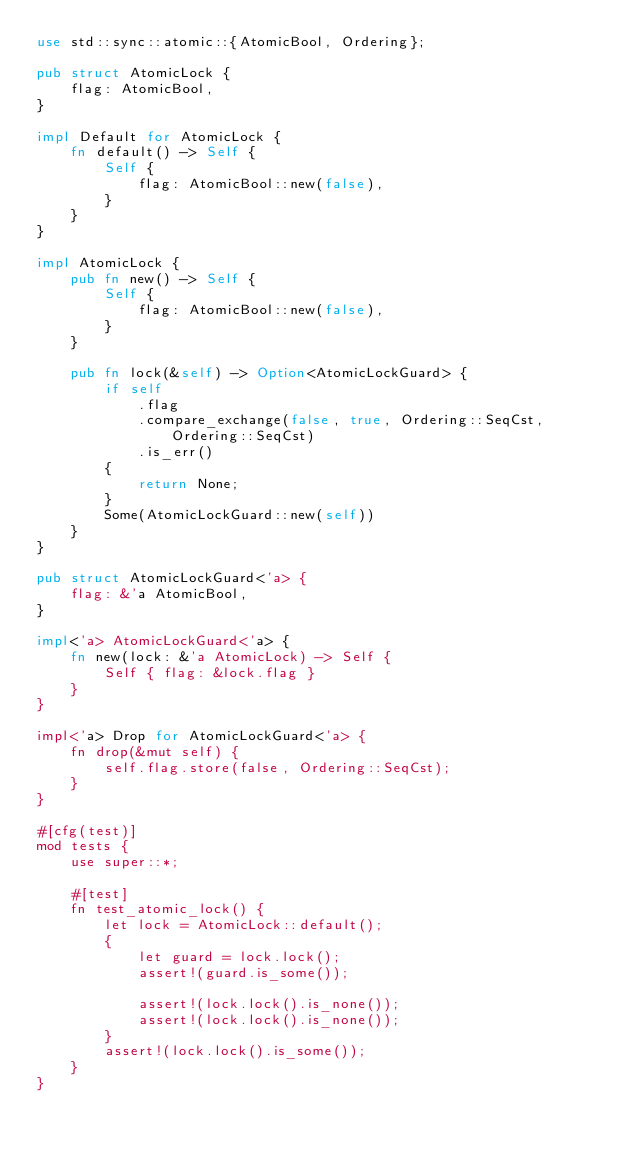Convert code to text. <code><loc_0><loc_0><loc_500><loc_500><_Rust_>use std::sync::atomic::{AtomicBool, Ordering};

pub struct AtomicLock {
    flag: AtomicBool,
}

impl Default for AtomicLock {
    fn default() -> Self {
        Self {
            flag: AtomicBool::new(false),
        }
    }
}

impl AtomicLock {
    pub fn new() -> Self {
        Self {
            flag: AtomicBool::new(false),
        }
    }

    pub fn lock(&self) -> Option<AtomicLockGuard> {
        if self
            .flag
            .compare_exchange(false, true, Ordering::SeqCst, Ordering::SeqCst)
            .is_err()
        {
            return None;
        }
        Some(AtomicLockGuard::new(self))
    }
}

pub struct AtomicLockGuard<'a> {
    flag: &'a AtomicBool,
}

impl<'a> AtomicLockGuard<'a> {
    fn new(lock: &'a AtomicLock) -> Self {
        Self { flag: &lock.flag }
    }
}

impl<'a> Drop for AtomicLockGuard<'a> {
    fn drop(&mut self) {
        self.flag.store(false, Ordering::SeqCst);
    }
}

#[cfg(test)]
mod tests {
    use super::*;

    #[test]
    fn test_atomic_lock() {
        let lock = AtomicLock::default();
        {
            let guard = lock.lock();
            assert!(guard.is_some());

            assert!(lock.lock().is_none());
            assert!(lock.lock().is_none());
        }
        assert!(lock.lock().is_some());
    }
}
</code> 